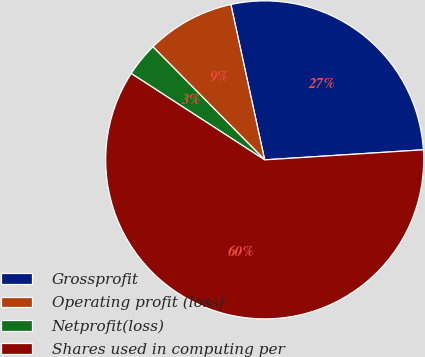<chart> <loc_0><loc_0><loc_500><loc_500><pie_chart><fcel>Grossprofit<fcel>Operating profit (loss)<fcel>Netprofit(loss)<fcel>Shares used in computing per<nl><fcel>27.4%<fcel>9.0%<fcel>3.45%<fcel>60.15%<nl></chart> 